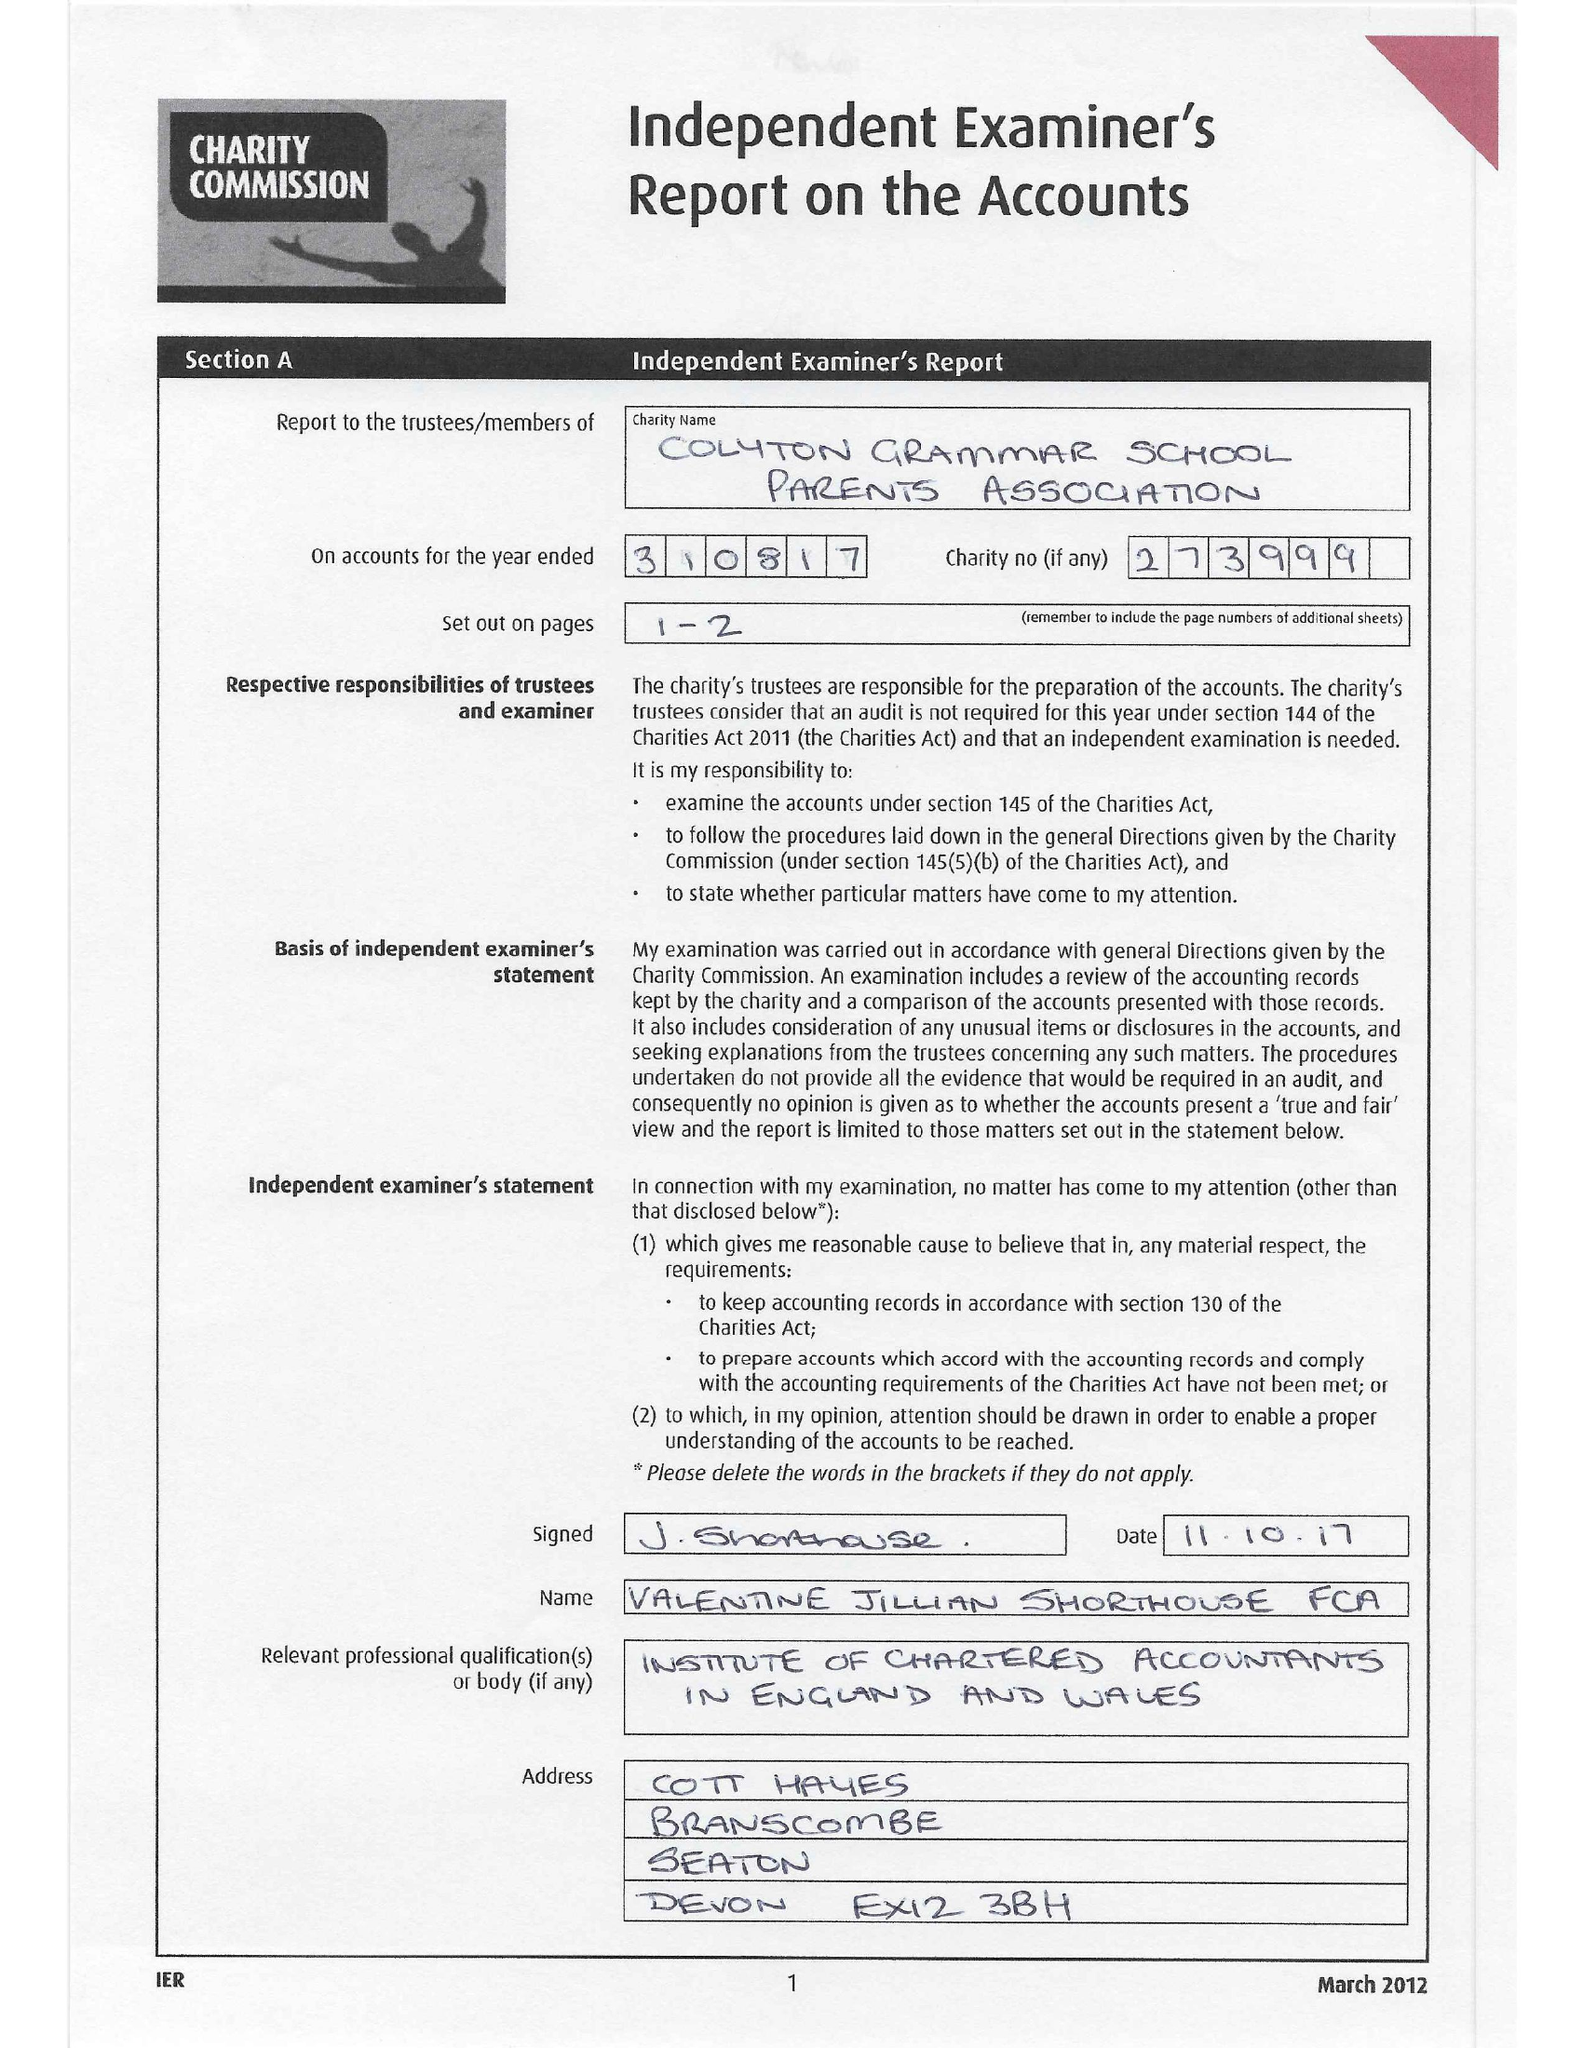What is the value for the charity_number?
Answer the question using a single word or phrase. 273999 